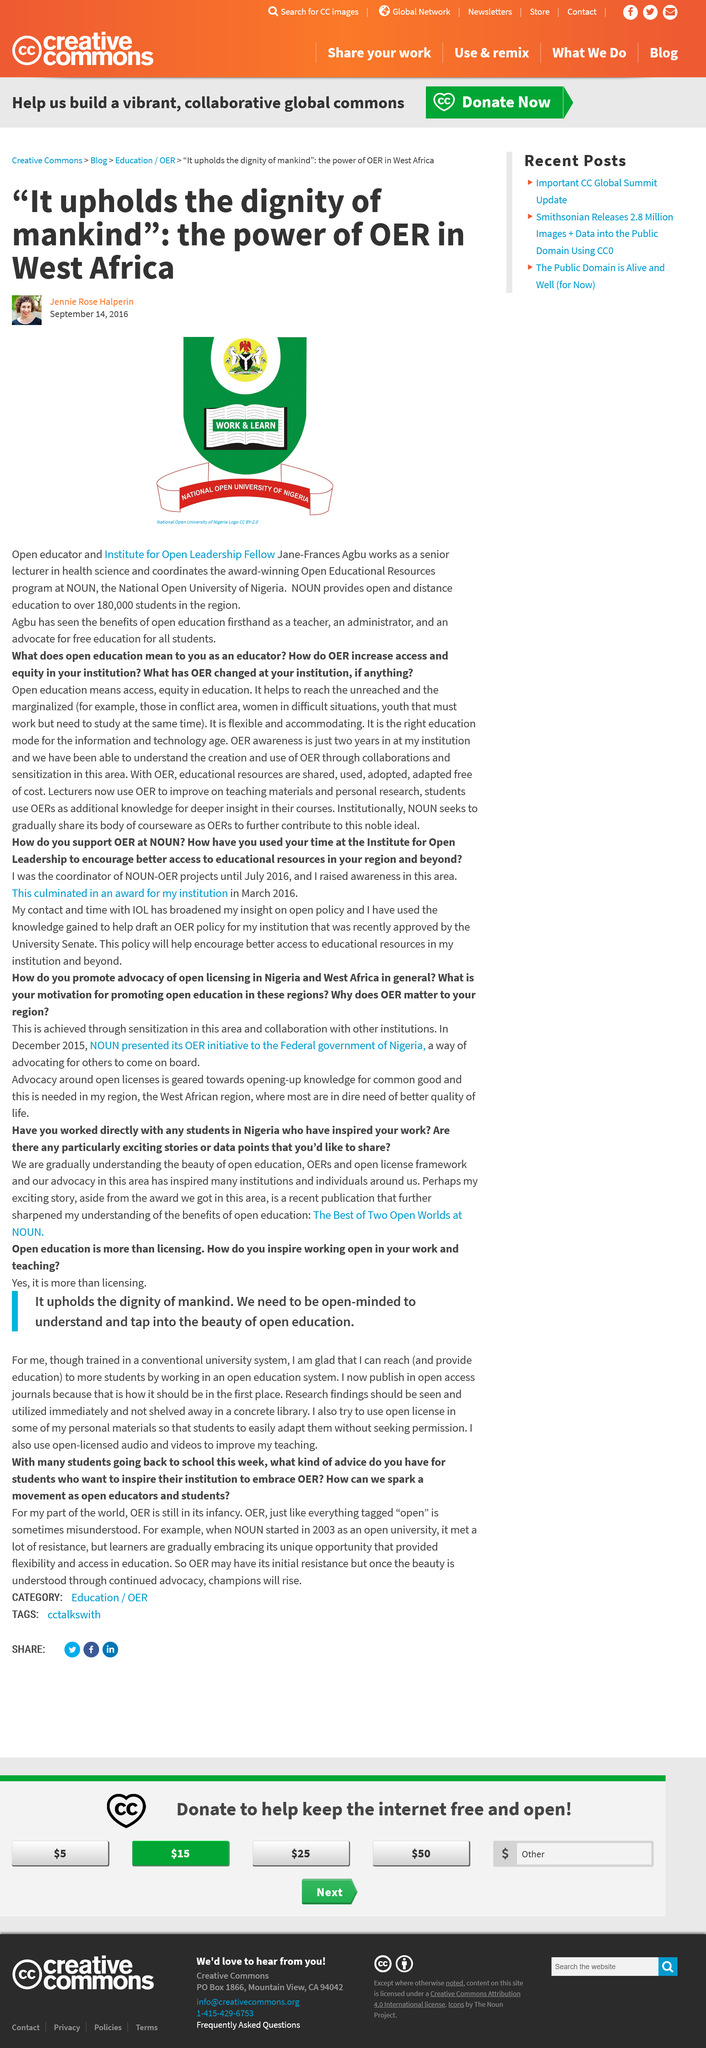Indicate a few pertinent items in this graphic. The logo in the image is for the National Open University of Nigeria. The Open Educational Resources program at the National Open University of Nigeria is commonly referred to as OER. Jane-Frances Agbu coordinates the Open Educational Resources program at the National Open University of Nigeria, which has won numerous awards. 